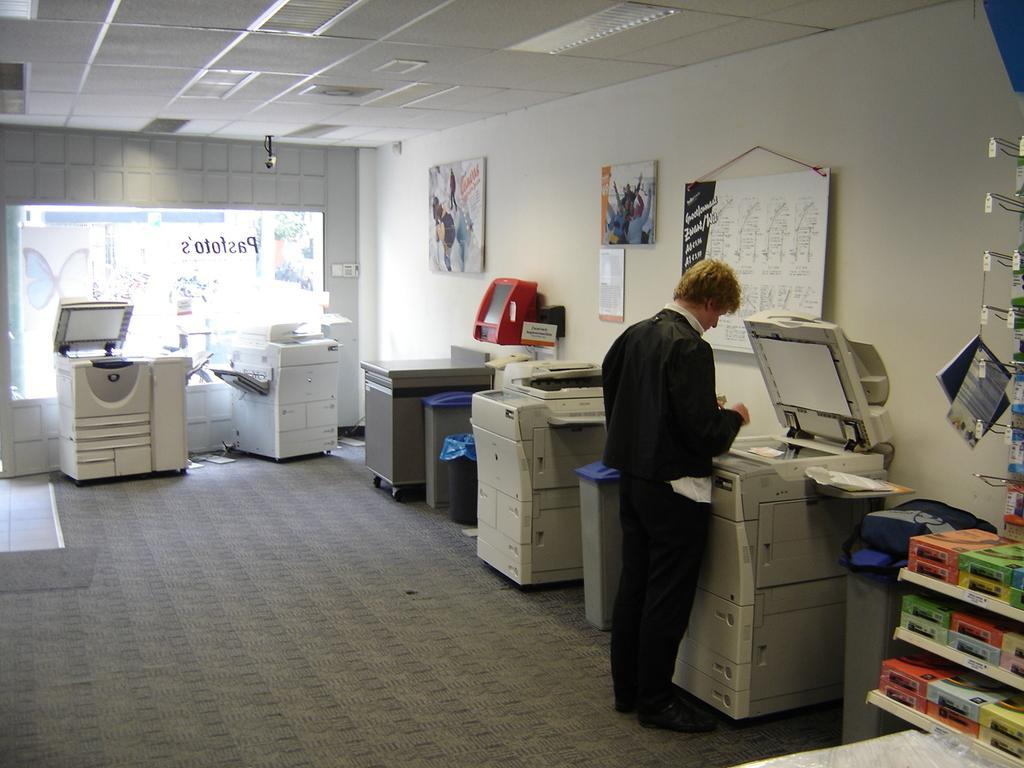In one or two sentences, can you explain what this image depicts? In the picture I can see a person wearing black dress is standing in front of a xerox machine and there is another machine beside him and there are few objects in the right corner and there are few other xerox machines in the background. 